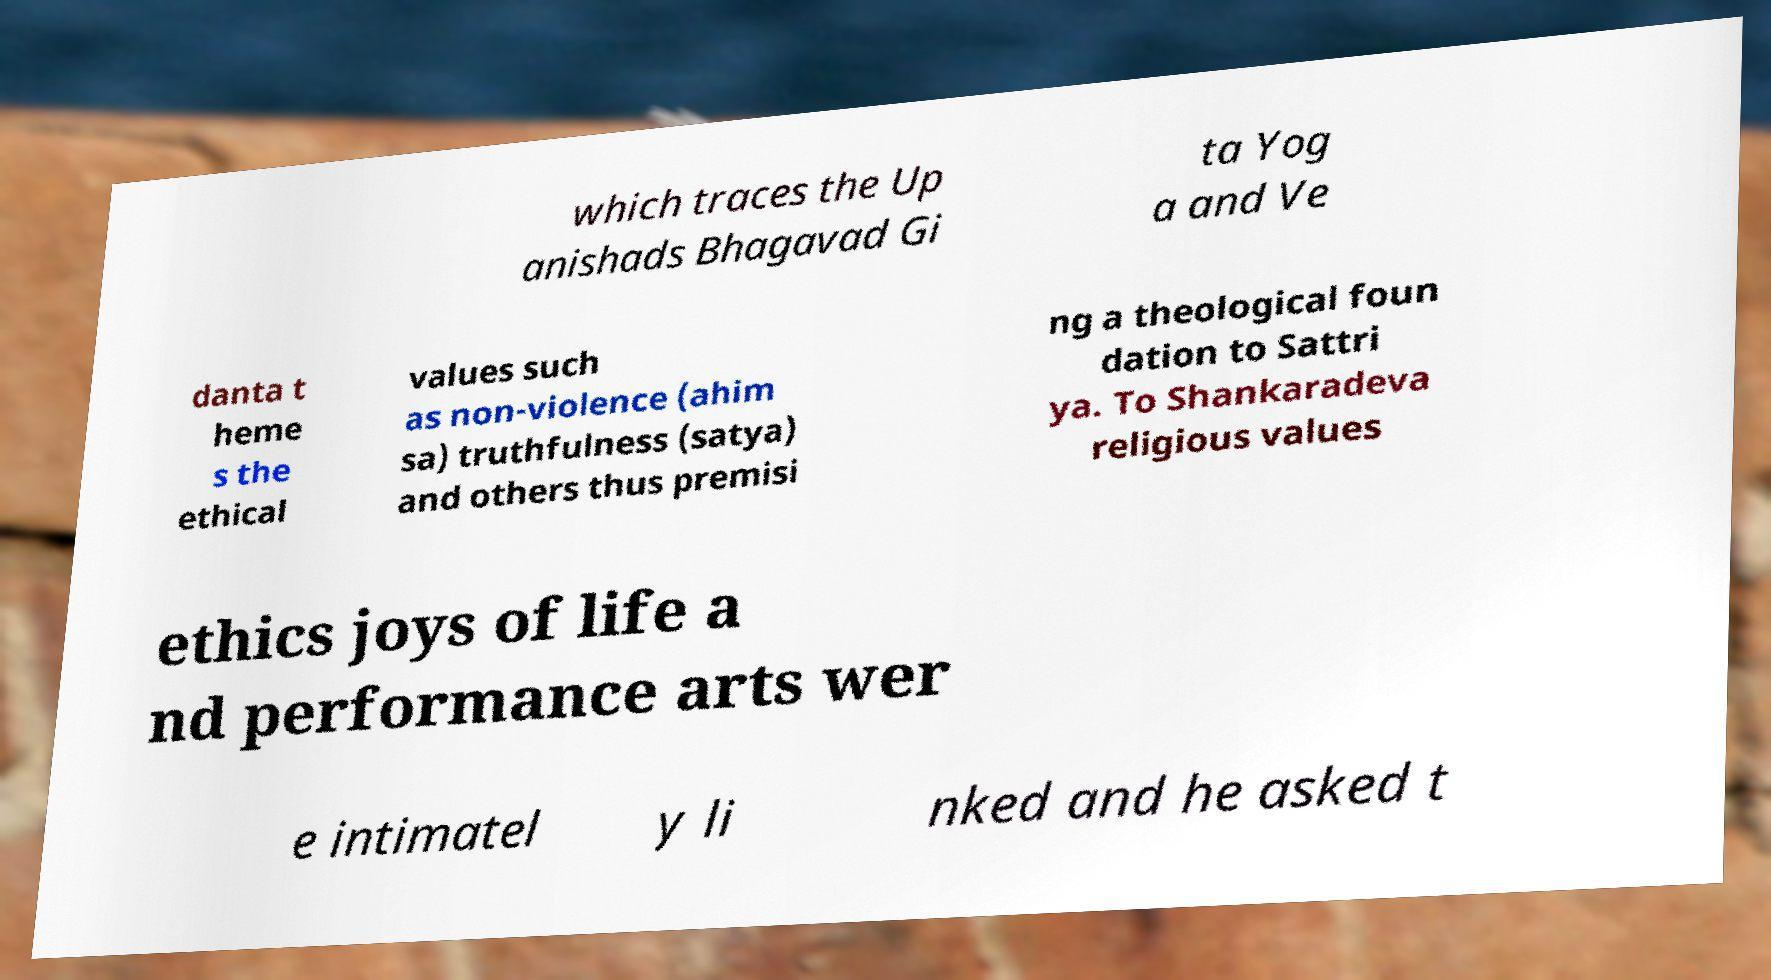Please read and relay the text visible in this image. What does it say? which traces the Up anishads Bhagavad Gi ta Yog a and Ve danta t heme s the ethical values such as non-violence (ahim sa) truthfulness (satya) and others thus premisi ng a theological foun dation to Sattri ya. To Shankaradeva religious values ethics joys of life a nd performance arts wer e intimatel y li nked and he asked t 